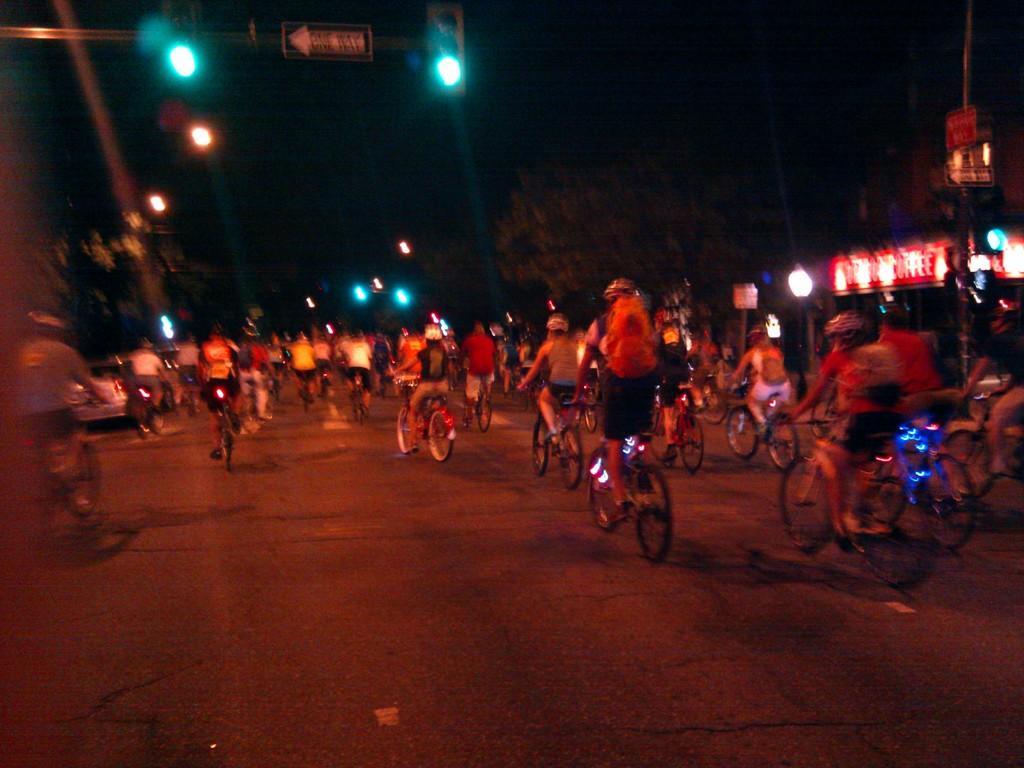Can you describe this image briefly? In this image, we can see people riding bicycles on the road. In the background, there are lights, boards, trees, poles and a dark view. 